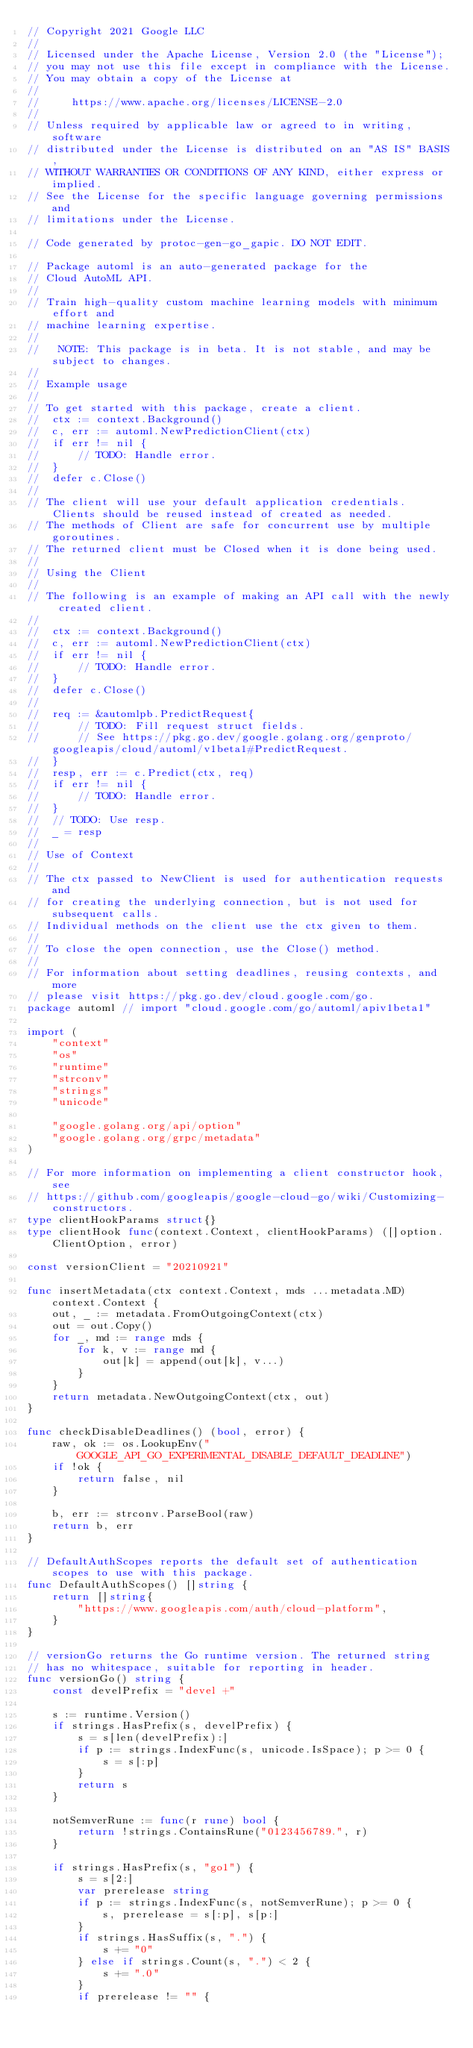<code> <loc_0><loc_0><loc_500><loc_500><_Go_>// Copyright 2021 Google LLC
//
// Licensed under the Apache License, Version 2.0 (the "License");
// you may not use this file except in compliance with the License.
// You may obtain a copy of the License at
//
//     https://www.apache.org/licenses/LICENSE-2.0
//
// Unless required by applicable law or agreed to in writing, software
// distributed under the License is distributed on an "AS IS" BASIS,
// WITHOUT WARRANTIES OR CONDITIONS OF ANY KIND, either express or implied.
// See the License for the specific language governing permissions and
// limitations under the License.

// Code generated by protoc-gen-go_gapic. DO NOT EDIT.

// Package automl is an auto-generated package for the
// Cloud AutoML API.
//
// Train high-quality custom machine learning models with minimum effort and
// machine learning expertise.
//
//   NOTE: This package is in beta. It is not stable, and may be subject to changes.
//
// Example usage
//
// To get started with this package, create a client.
//  ctx := context.Background()
//  c, err := automl.NewPredictionClient(ctx)
//  if err != nil {
//  	// TODO: Handle error.
//  }
//  defer c.Close()
//
// The client will use your default application credentials. Clients should be reused instead of created as needed.
// The methods of Client are safe for concurrent use by multiple goroutines.
// The returned client must be Closed when it is done being used.
//
// Using the Client
//
// The following is an example of making an API call with the newly created client.
//
//  ctx := context.Background()
//  c, err := automl.NewPredictionClient(ctx)
//  if err != nil {
//  	// TODO: Handle error.
//  }
//  defer c.Close()
//
//  req := &automlpb.PredictRequest{
//  	// TODO: Fill request struct fields.
//  	// See https://pkg.go.dev/google.golang.org/genproto/googleapis/cloud/automl/v1beta1#PredictRequest.
//  }
//  resp, err := c.Predict(ctx, req)
//  if err != nil {
//  	// TODO: Handle error.
//  }
//  // TODO: Use resp.
//  _ = resp
//
// Use of Context
//
// The ctx passed to NewClient is used for authentication requests and
// for creating the underlying connection, but is not used for subsequent calls.
// Individual methods on the client use the ctx given to them.
//
// To close the open connection, use the Close() method.
//
// For information about setting deadlines, reusing contexts, and more
// please visit https://pkg.go.dev/cloud.google.com/go.
package automl // import "cloud.google.com/go/automl/apiv1beta1"

import (
	"context"
	"os"
	"runtime"
	"strconv"
	"strings"
	"unicode"

	"google.golang.org/api/option"
	"google.golang.org/grpc/metadata"
)

// For more information on implementing a client constructor hook, see
// https://github.com/googleapis/google-cloud-go/wiki/Customizing-constructors.
type clientHookParams struct{}
type clientHook func(context.Context, clientHookParams) ([]option.ClientOption, error)

const versionClient = "20210921"

func insertMetadata(ctx context.Context, mds ...metadata.MD) context.Context {
	out, _ := metadata.FromOutgoingContext(ctx)
	out = out.Copy()
	for _, md := range mds {
		for k, v := range md {
			out[k] = append(out[k], v...)
		}
	}
	return metadata.NewOutgoingContext(ctx, out)
}

func checkDisableDeadlines() (bool, error) {
	raw, ok := os.LookupEnv("GOOGLE_API_GO_EXPERIMENTAL_DISABLE_DEFAULT_DEADLINE")
	if !ok {
		return false, nil
	}

	b, err := strconv.ParseBool(raw)
	return b, err
}

// DefaultAuthScopes reports the default set of authentication scopes to use with this package.
func DefaultAuthScopes() []string {
	return []string{
		"https://www.googleapis.com/auth/cloud-platform",
	}
}

// versionGo returns the Go runtime version. The returned string
// has no whitespace, suitable for reporting in header.
func versionGo() string {
	const develPrefix = "devel +"

	s := runtime.Version()
	if strings.HasPrefix(s, develPrefix) {
		s = s[len(develPrefix):]
		if p := strings.IndexFunc(s, unicode.IsSpace); p >= 0 {
			s = s[:p]
		}
		return s
	}

	notSemverRune := func(r rune) bool {
		return !strings.ContainsRune("0123456789.", r)
	}

	if strings.HasPrefix(s, "go1") {
		s = s[2:]
		var prerelease string
		if p := strings.IndexFunc(s, notSemverRune); p >= 0 {
			s, prerelease = s[:p], s[p:]
		}
		if strings.HasSuffix(s, ".") {
			s += "0"
		} else if strings.Count(s, ".") < 2 {
			s += ".0"
		}
		if prerelease != "" {</code> 